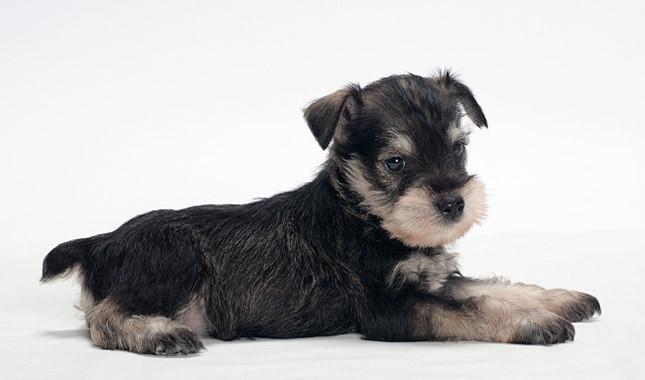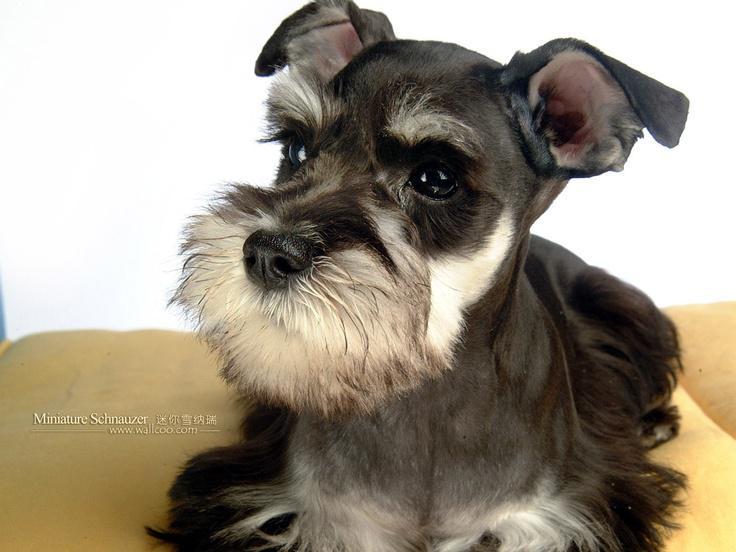The first image is the image on the left, the second image is the image on the right. Given the left and right images, does the statement "There is at least one dog completely surrounded by whiteness with no shadows of its tail." hold true? Answer yes or no. No. 